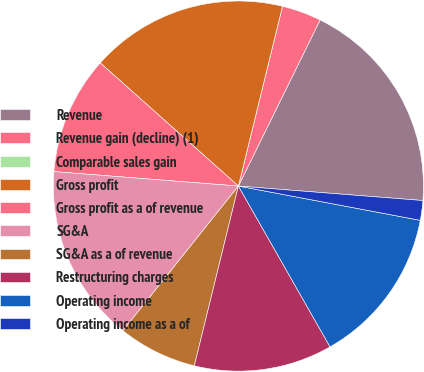Convert chart to OTSL. <chart><loc_0><loc_0><loc_500><loc_500><pie_chart><fcel>Revenue<fcel>Revenue gain (decline) (1)<fcel>Comparable sales gain<fcel>Gross profit<fcel>Gross profit as a of revenue<fcel>SG&A<fcel>SG&A as a of revenue<fcel>Restructuring charges<fcel>Operating income<fcel>Operating income as a of<nl><fcel>18.97%<fcel>3.45%<fcel>0.0%<fcel>17.24%<fcel>10.34%<fcel>15.52%<fcel>6.9%<fcel>12.07%<fcel>13.79%<fcel>1.72%<nl></chart> 